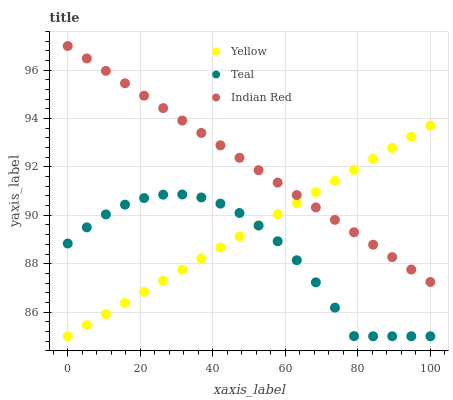Does Teal have the minimum area under the curve?
Answer yes or no. Yes. Does Indian Red have the maximum area under the curve?
Answer yes or no. Yes. Does Yellow have the minimum area under the curve?
Answer yes or no. No. Does Yellow have the maximum area under the curve?
Answer yes or no. No. Is Yellow the smoothest?
Answer yes or no. Yes. Is Teal the roughest?
Answer yes or no. Yes. Is Teal the smoothest?
Answer yes or no. No. Is Yellow the roughest?
Answer yes or no. No. Does Teal have the lowest value?
Answer yes or no. Yes. Does Indian Red have the highest value?
Answer yes or no. Yes. Does Yellow have the highest value?
Answer yes or no. No. Is Teal less than Indian Red?
Answer yes or no. Yes. Is Indian Red greater than Teal?
Answer yes or no. Yes. Does Yellow intersect Indian Red?
Answer yes or no. Yes. Is Yellow less than Indian Red?
Answer yes or no. No. Is Yellow greater than Indian Red?
Answer yes or no. No. Does Teal intersect Indian Red?
Answer yes or no. No. 